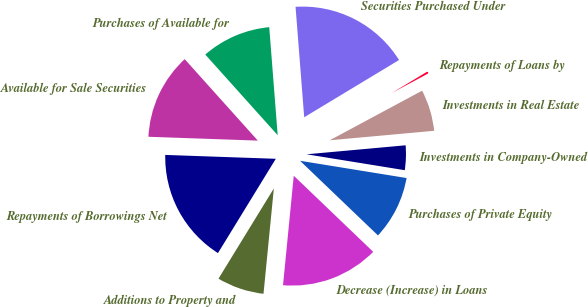Convert chart. <chart><loc_0><loc_0><loc_500><loc_500><pie_chart><fcel>Additions to Property and<fcel>Decrease (Increase) in Loans<fcel>Purchases of Private Equity<fcel>Investments in Company-Owned<fcel>Investments in Real Estate<fcel>Repayments of Loans by<fcel>Securities Purchased Under<fcel>Purchases of Available for<fcel>Available for Sale Securities<fcel>Repayments of Borrowings Net<nl><fcel>7.2%<fcel>14.4%<fcel>9.6%<fcel>4.0%<fcel>6.4%<fcel>0.8%<fcel>17.6%<fcel>10.4%<fcel>12.8%<fcel>16.8%<nl></chart> 